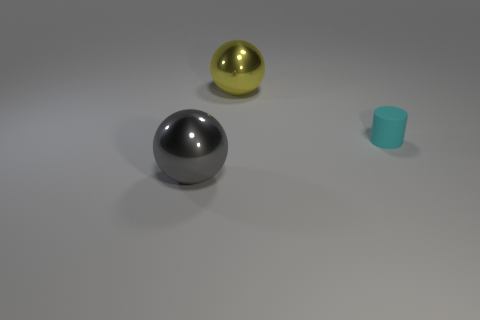Add 3 shiny balls. How many objects exist? 6 Subtract all balls. How many objects are left? 1 Add 1 small cyan rubber cylinders. How many small cyan rubber cylinders exist? 2 Subtract 0 red blocks. How many objects are left? 3 Subtract all yellow spheres. Subtract all tiny matte objects. How many objects are left? 1 Add 3 small cyan things. How many small cyan things are left? 4 